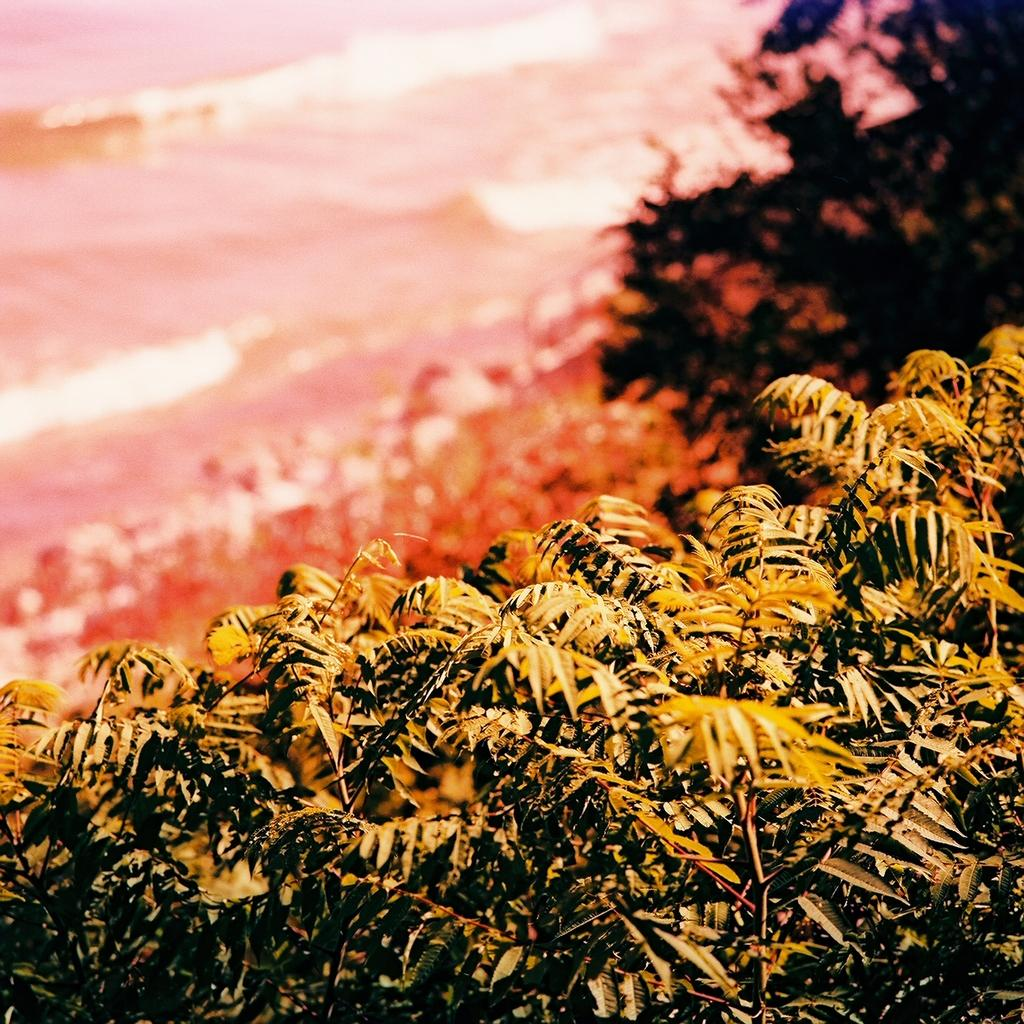What is the primary feature of the image? There are many trees in the image. What can be seen in the distance in the image? There is water visible in the background of the image. How would you describe the appearance of the background? The background appears blurred. What type of guide is leading the group through the town in the image? There is no group or town visible in the image, and no guide is leading anyone. 